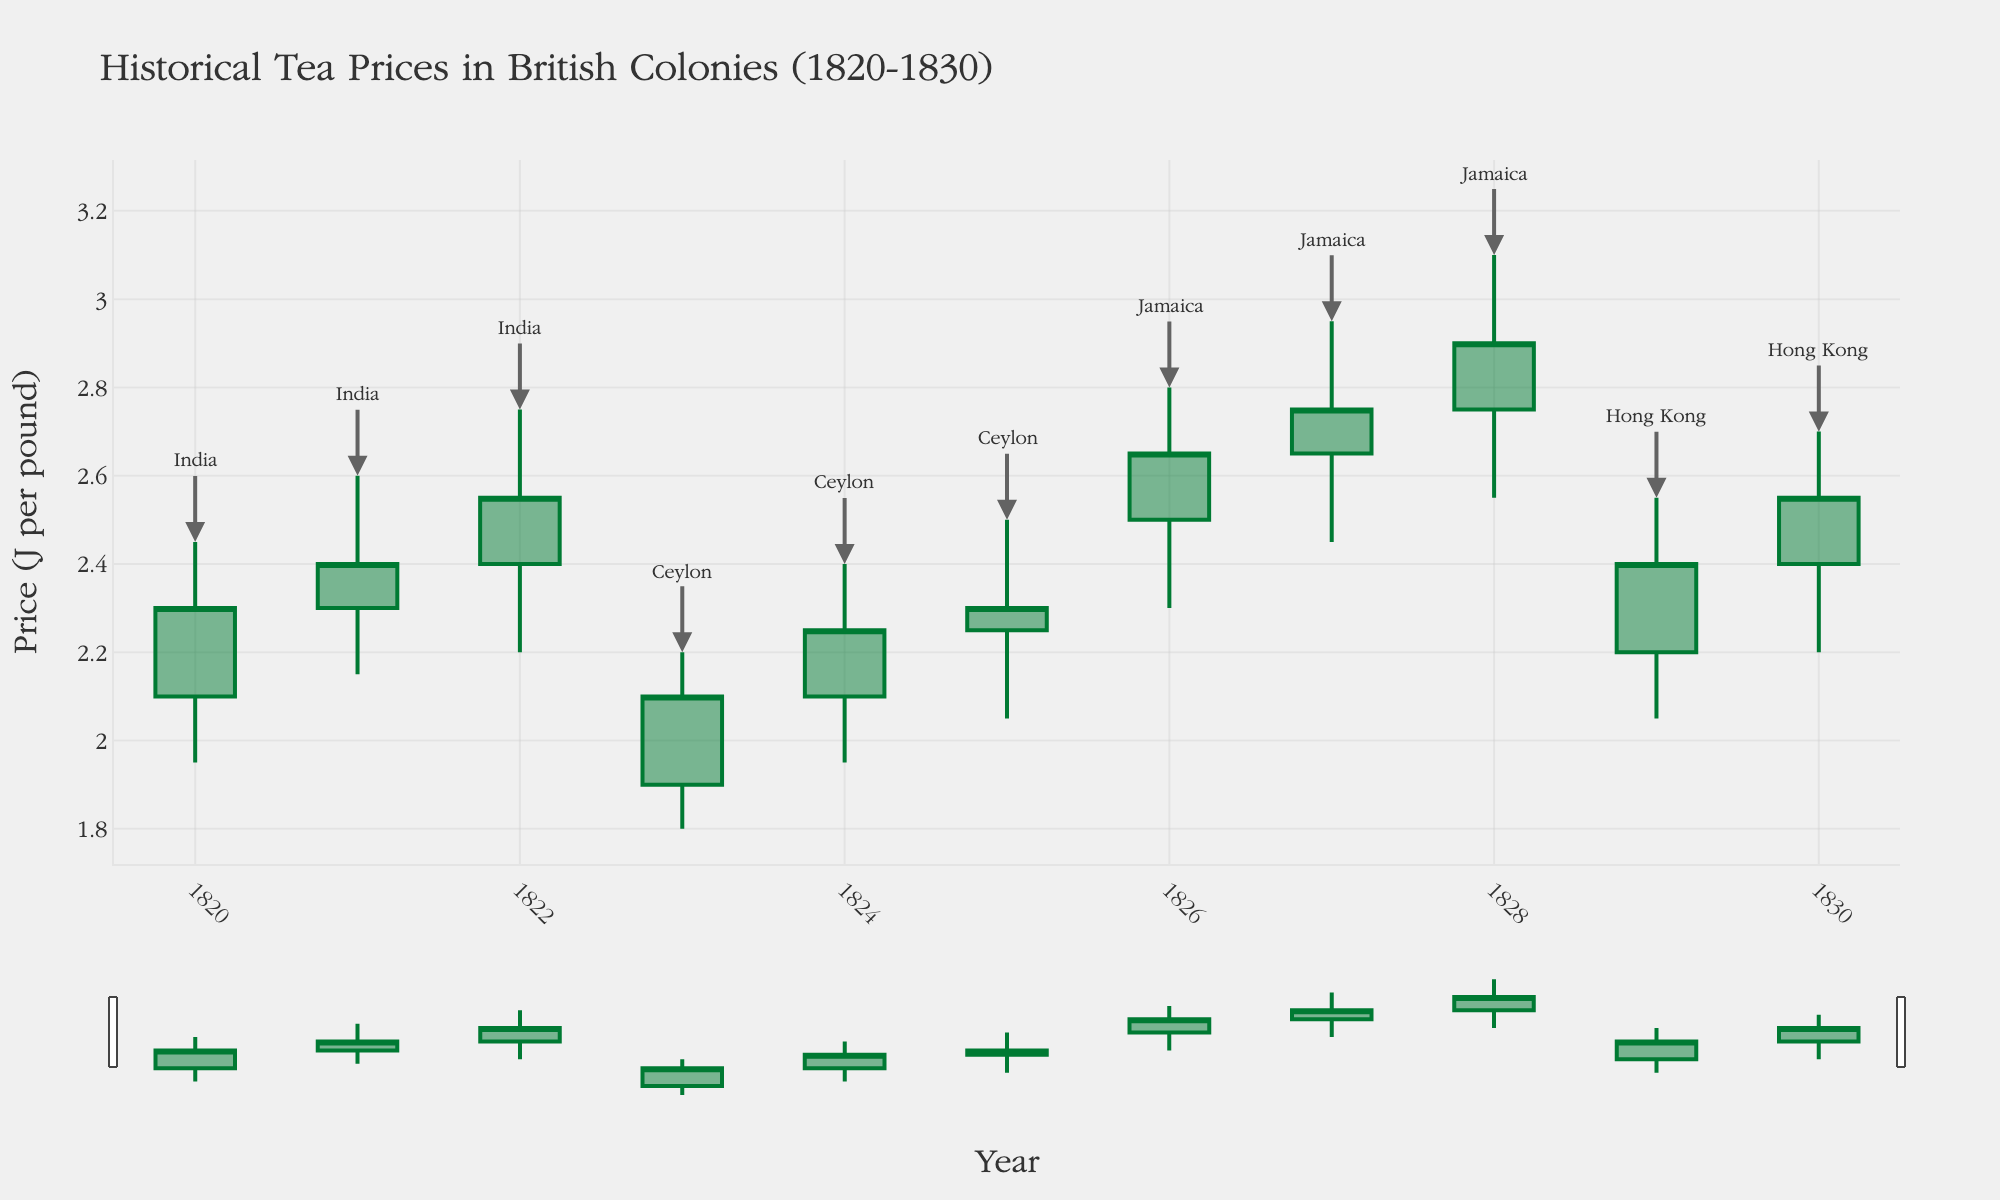What's the title of the chart? The title is displayed at the top of the chart in a larger font compared to the rest of the text. It provides the main context for the visual data.
Answer: Historical Tea Prices in British Colonies (1820-1830) What is the general trend of tea prices in India from 1820 to 1822? To determine the trend, observe the opening and closing prices for India for each year and note the changes. The data shows an increasing trend from £2.10 in 1820 to £2.55 in 1822.
Answer: Increasing Which year in Ceylon had the lowest tea price and what was that price? Identify the lowest 'Low' value for Ceylon's data points. 1823 had the lowest price at £1.80.
Answer: 1823, £1.80 Comparing India and Jamaica, which colony had a higher closing price on average from 1820 to 1828? Calculate the average closing price for both colonies over their respective periods. India's average is (2.30 + 2.40 + 2.55) / 3 ≈ £2.42. Jamaica's average is (2.65 + 2.75 + 2.90) / 3 ≈ £2.77.
Answer: Jamaica What can you infer about the stability of tea prices in Hong Kong between 1829 and 1830? Evaluate the range between opening and closing prices and high and low prices. Smaller ranges imply more stability. Prices in Hong Kong from 1829-1830 showed minor fluctuations, indicating stability.
Answer: Stable Which colony experienced the highest maximum tea price in any given year, and what was the price? Look for the highest 'High' value across all colonies. Jamaica in 1828 had the highest maximum price at £3.10.
Answer: Jamaica, £3.10 How do the colors of the candlesticks indicate the change in tea prices? In the chart, green candlesticks indicate an increasing price where the closing price is higher than the opening price, while red candlesticks show a decreasing price.
Answer: Green indicates increase, red indicates decrease Between India in 1820 and Jamaica in 1828, which colony had the higher volatility in tea prices, and why? Volatility is indicated by the difference between the high and low prices. India in 1820: 2.45 - 1.95 = £0.50. Jamaica in 1828: 3.10 - 2.55 = £0.55.
Answer: Jamaica, larger high-low range What year did Ceylon experience its highest tea price, and what was the closing price that year? Find the highest 'High' value for Ceylon and identify the corresponding year and closing price. In 1825, Ceylon had its highest price at £2.50 and a closing price of £2.30.
Answer: 1825, £2.30 For which year is the largest price increase observed in India based on the OHLC data and what is the price difference? Calculate the difference between opening and closing prices for each year and identify the largest increase. In 1821, the difference is £2.40 - £2.30 = £0.10, in 1822, it is £2.55 - £2.40 = £0.15. The largest increase is from 1821 to 1822.
Answer: 1822, £0.15 